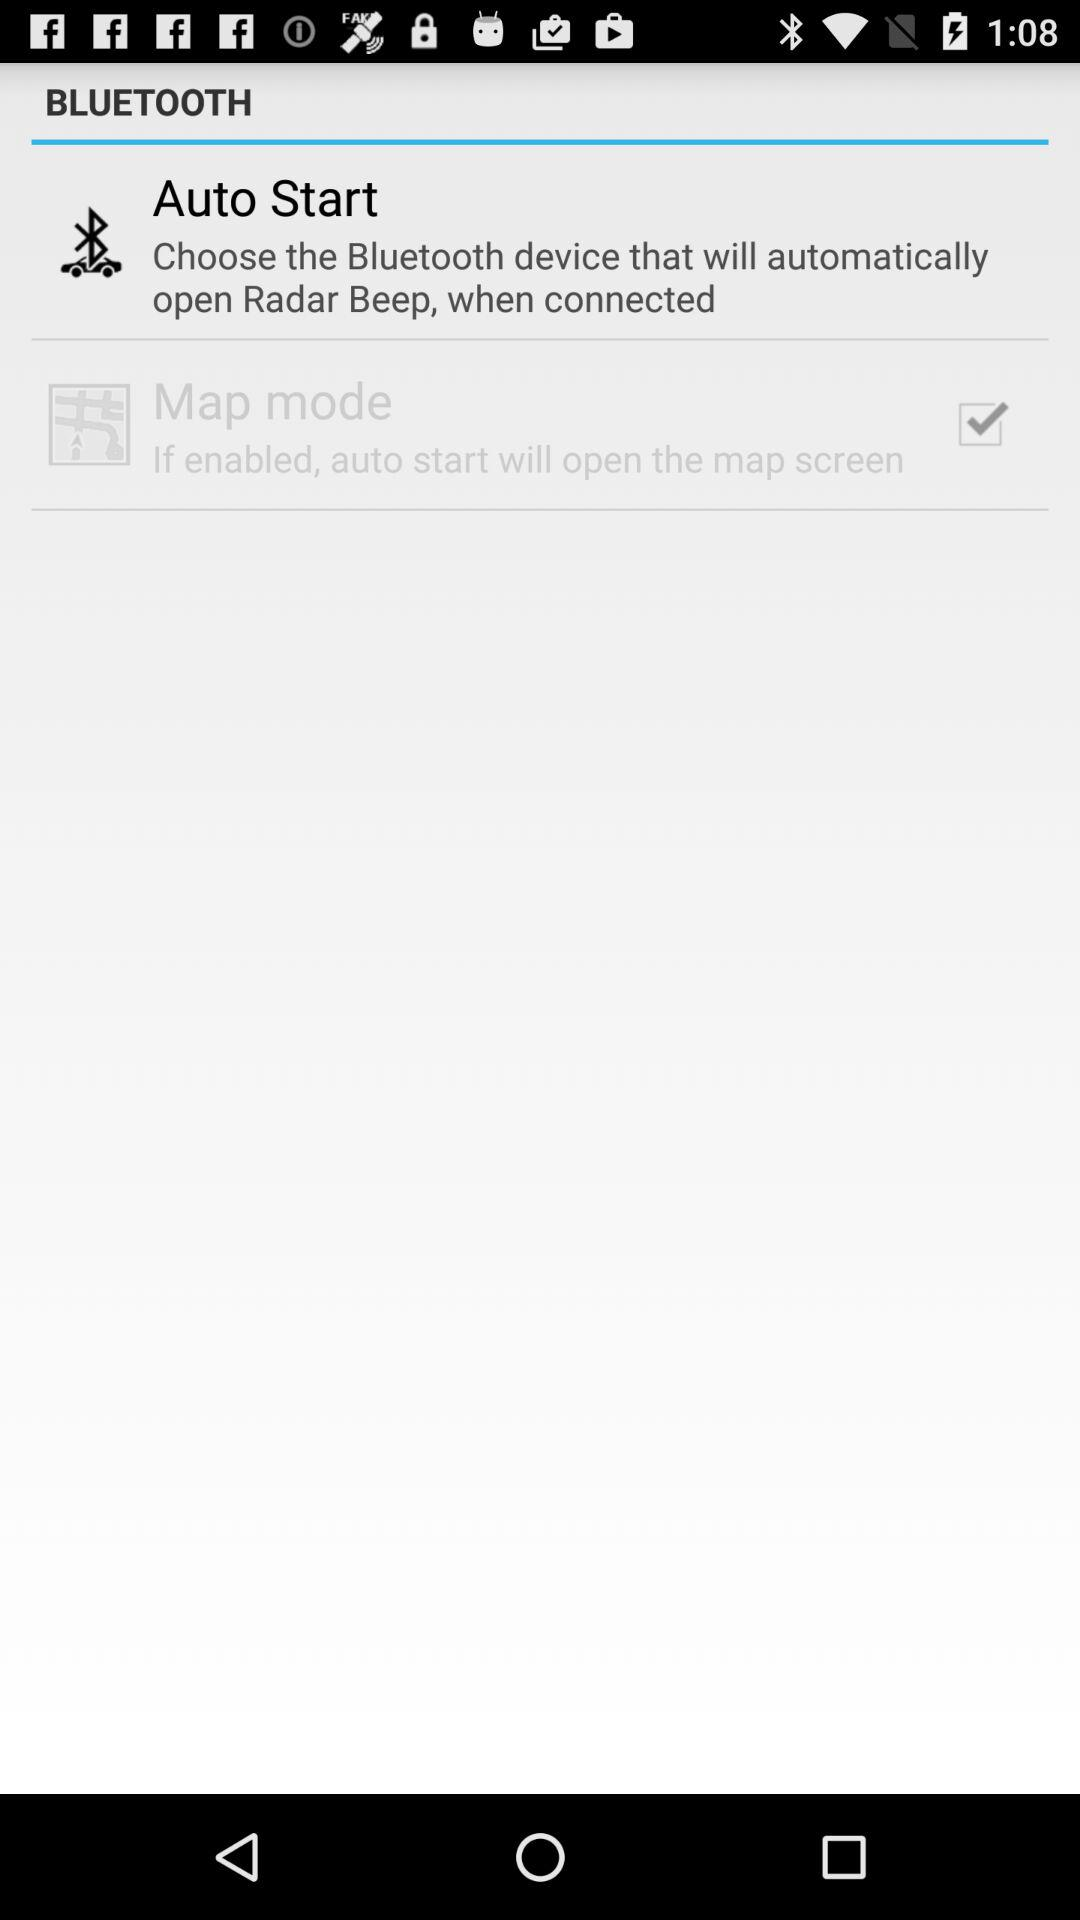What is the instruction for "Auto Start"? The instruction is to "Choose the Bluetooth device that will automatically open Radar Beep, when connected". 